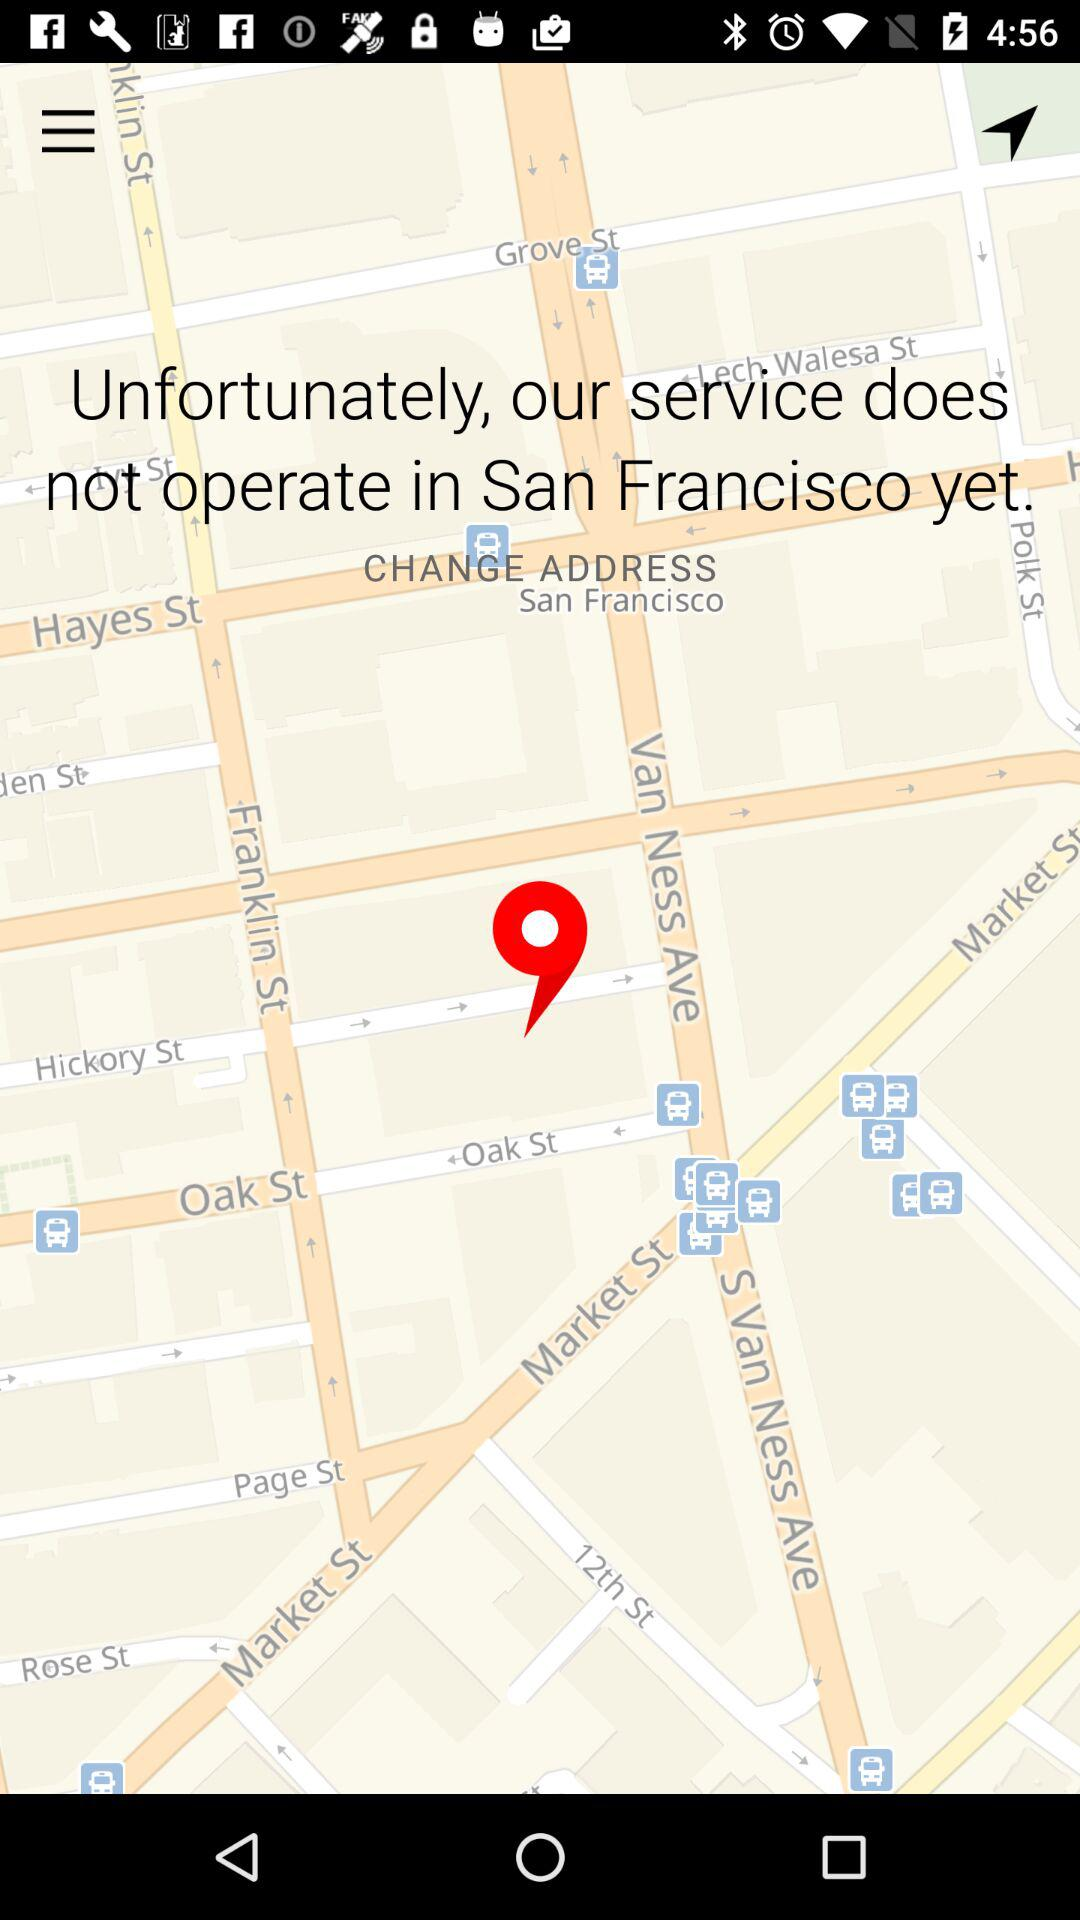Where do the services not operate? The services do not operate in San Francisco. 